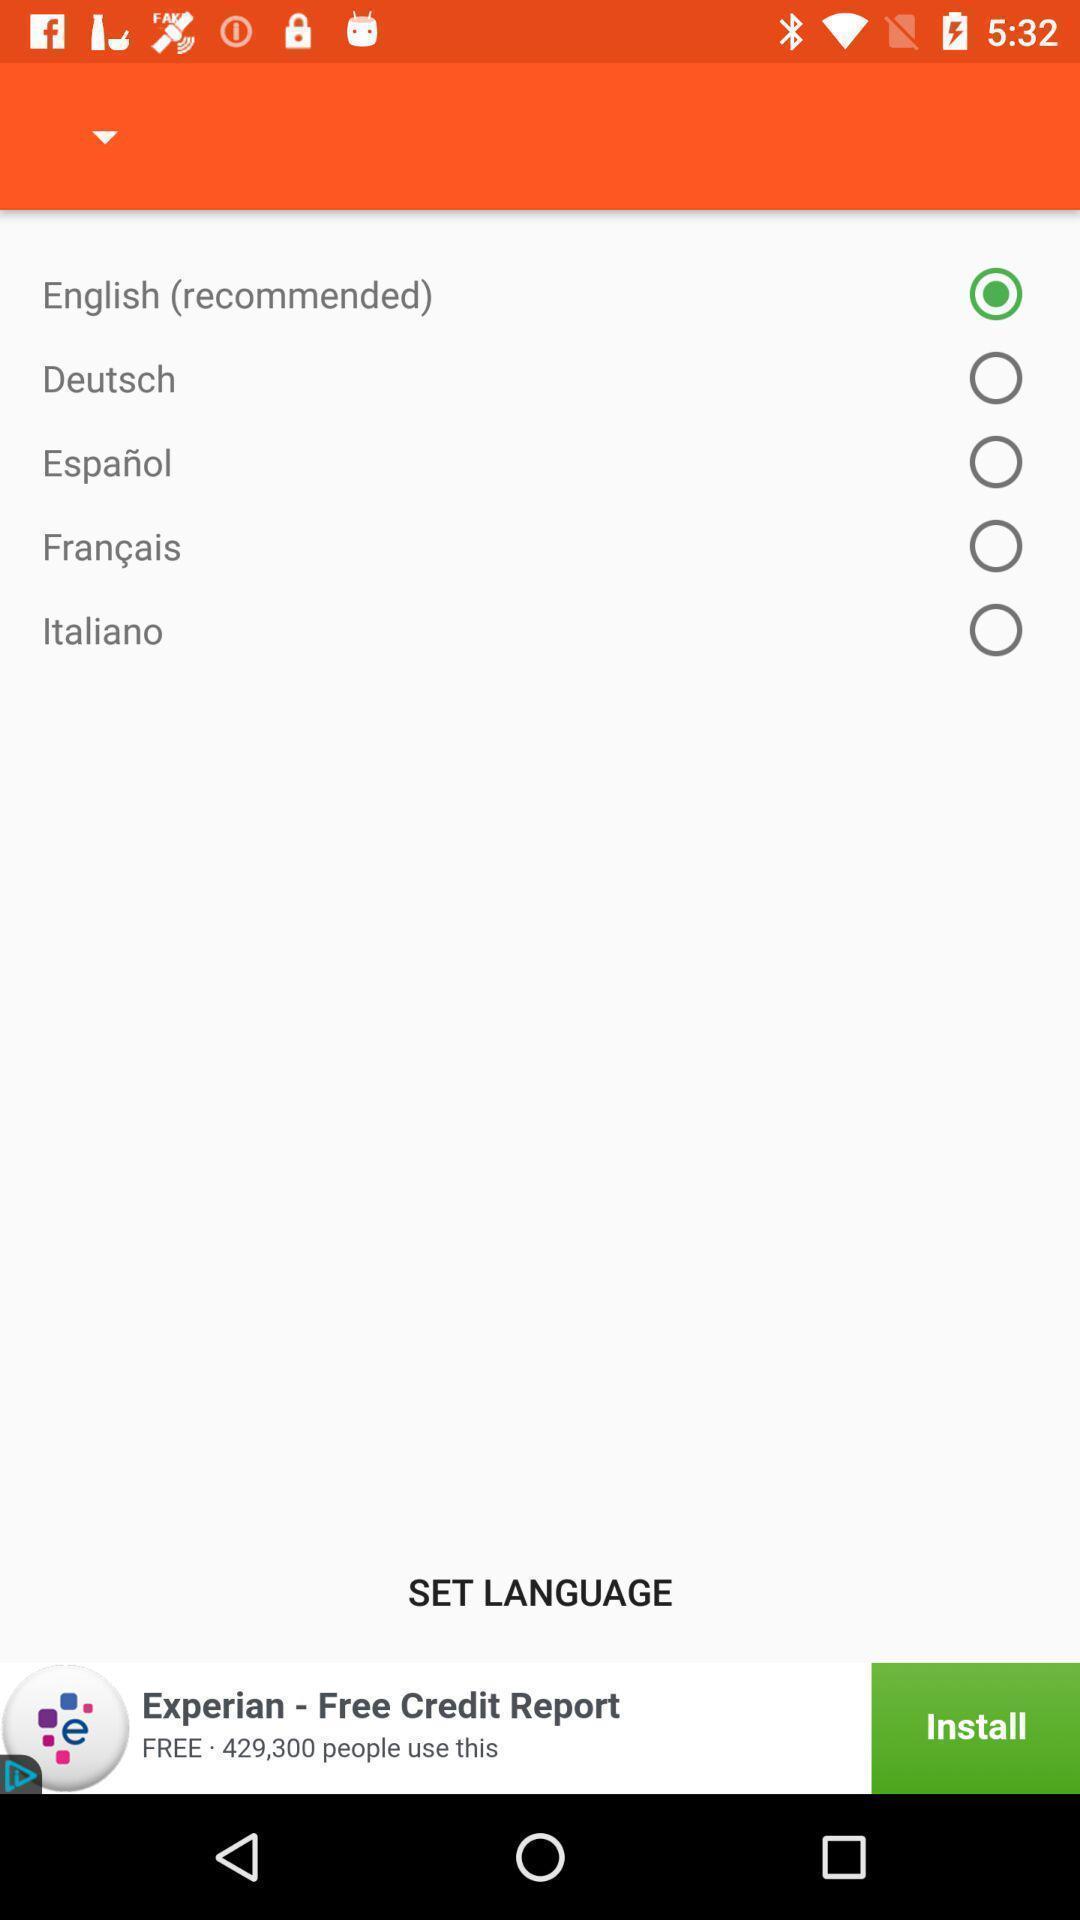Give me a summary of this screen capture. Page showing various language for food recipe app. 